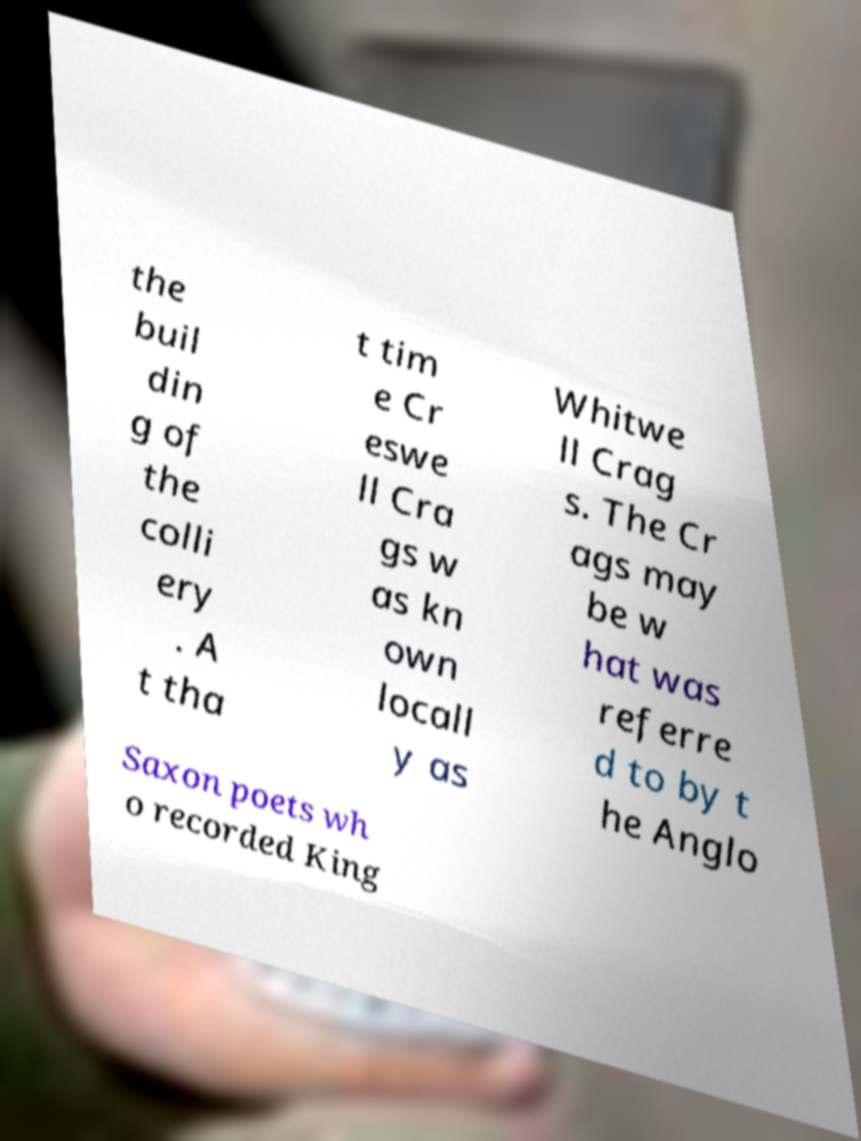Can you read and provide the text displayed in the image?This photo seems to have some interesting text. Can you extract and type it out for me? the buil din g of the colli ery . A t tha t tim e Cr eswe ll Cra gs w as kn own locall y as Whitwe ll Crag s. The Cr ags may be w hat was referre d to by t he Anglo Saxon poets wh o recorded King 